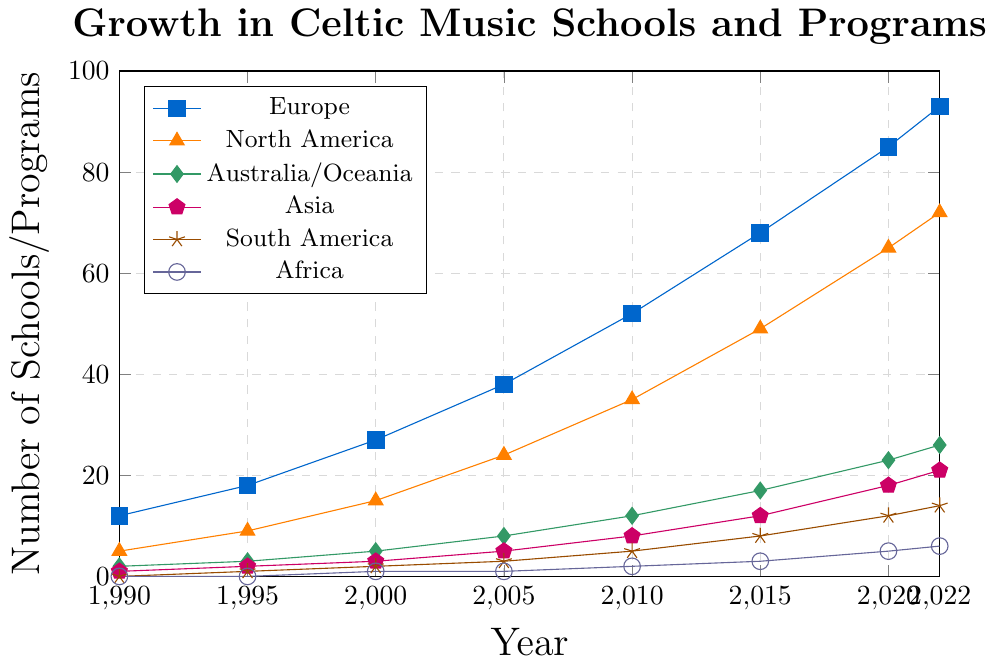What continent had the largest increase in the number of Celtic music schools and programs from 1990 to 2022? Examine the plot and identify the change in the number of schools/programs for each continent between 1990 and 2022. Europe's increase: 93 - 12 = 81, North America's increase: 72 - 5 = 67, Australia/Oceania's increase: 26 - 2 = 24, Asia's increase: 21 - 1 = 20, South America's increase: 14 - 0 = 14, Africa's increase: 6 - 0 = 6. Europe has the largest increase
Answer: Europe How many Celtic music schools and programs were present globally in 2000? Sum the number of schools/programs in 2000 across all continents. Europe: 27, North America: 15, Australia/Oceania: 5, Asia: 3, South America: 2, Africa: 1. Total: 27 + 15 + 5 + 3 + 2 + 1 = 53
Answer: 53 In which year did North America surpass 50 Celtic music schools and programs? Look at the trend line for North America and find the year when the number passed 50. North America surpassed 50 between 2010 and 2015. In 2015, the number was 49 and increased to 65 in 2020. Therefore, it surpassed 50 in 2015.
Answer: 2015 What is the average growth rate per year for Celtic music schools and programs in Asia from 1990 to 2022? Calculate the difference in the number of schools/programs between 1990 and 2022, then divide by the number of years. Growth in Asia: 21 - 1 = 20, Number of years: 2022 - 1990 = 32. Average growth rate per year: 20 / 32 ≈ 0.625
Answer: 0.625 Which continent had the least number of Celtic music schools and programs in 2015? Examine the number of schools/programs for each continent in 2015. Europe: 68, North America: 49, Australia/Oceania: 17, Asia: 12, South America: 8, Africa: 3. Africa has the least number.
Answer: Africa By how much did the number of Celtic music schools and programs in Australia/Oceania grow between 2000 and 2010? Calculate the difference in the number of schools/programs between 2000 and 2010 for Australia/Oceania. In 2000: 5, in 2010: 12. Growth: 12 - 5 = 7
Answer: 7 Is the growth rate of Celtic music schools and programs in South America from 1990 to 2022 linear? Examine the trend line for South America. The growth appears to be steady and incremental, which suggests a near-linear increase. To confirm, check if the yearly increments are approximately constant. From the plot, the increase seems consistent.
Answer: Yes Which two continents had identical numbers of Celtic music schools and programs in 2005? Compare the number of schools/programs for each continent in 2005. Europe: 38, North America: 24, Australia/Oceania: 8, Asia: 5, South America: 3, Africa: 1. Only one pair has identical numbers: Asia and South America with 5 schools/programs each.
Answer: Asia and South America Between 2010 and 2020, which continent experienced the fastest growth in the number of Celtic music schools and programs? Calculate the difference in the number of schools/programs between 2010 and 2020 for each continent. Europe: 85 - 52 = 33, North America: 65 - 35 = 30, Australia/Oceania: 23 - 12 = 11, Asia: 18 - 8 = 10, South America: 12 - 5 = 7, Africa: 5 - 2 = 3. Europe experienced the fastest growth.
Answer: Europe In which year did Africa have at least 3 Celtic music schools and programs for the first time? Find the year when the number in Africa reached or exceeded 3 for the first time. From the plot, this occurs after 2015. By 2015, Africa had 3 schools/programs.
Answer: 2015 